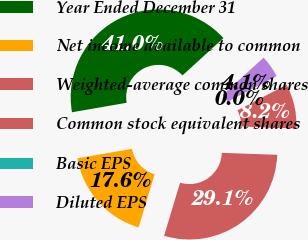<chart> <loc_0><loc_0><loc_500><loc_500><pie_chart><fcel>Year Ended December 31<fcel>Net income available to common<fcel>Weighted-average common shares<fcel>Common stock equivalent shares<fcel>Basic EPS<fcel>Diluted EPS<nl><fcel>40.97%<fcel>17.6%<fcel>29.09%<fcel>8.21%<fcel>0.01%<fcel>4.11%<nl></chart> 